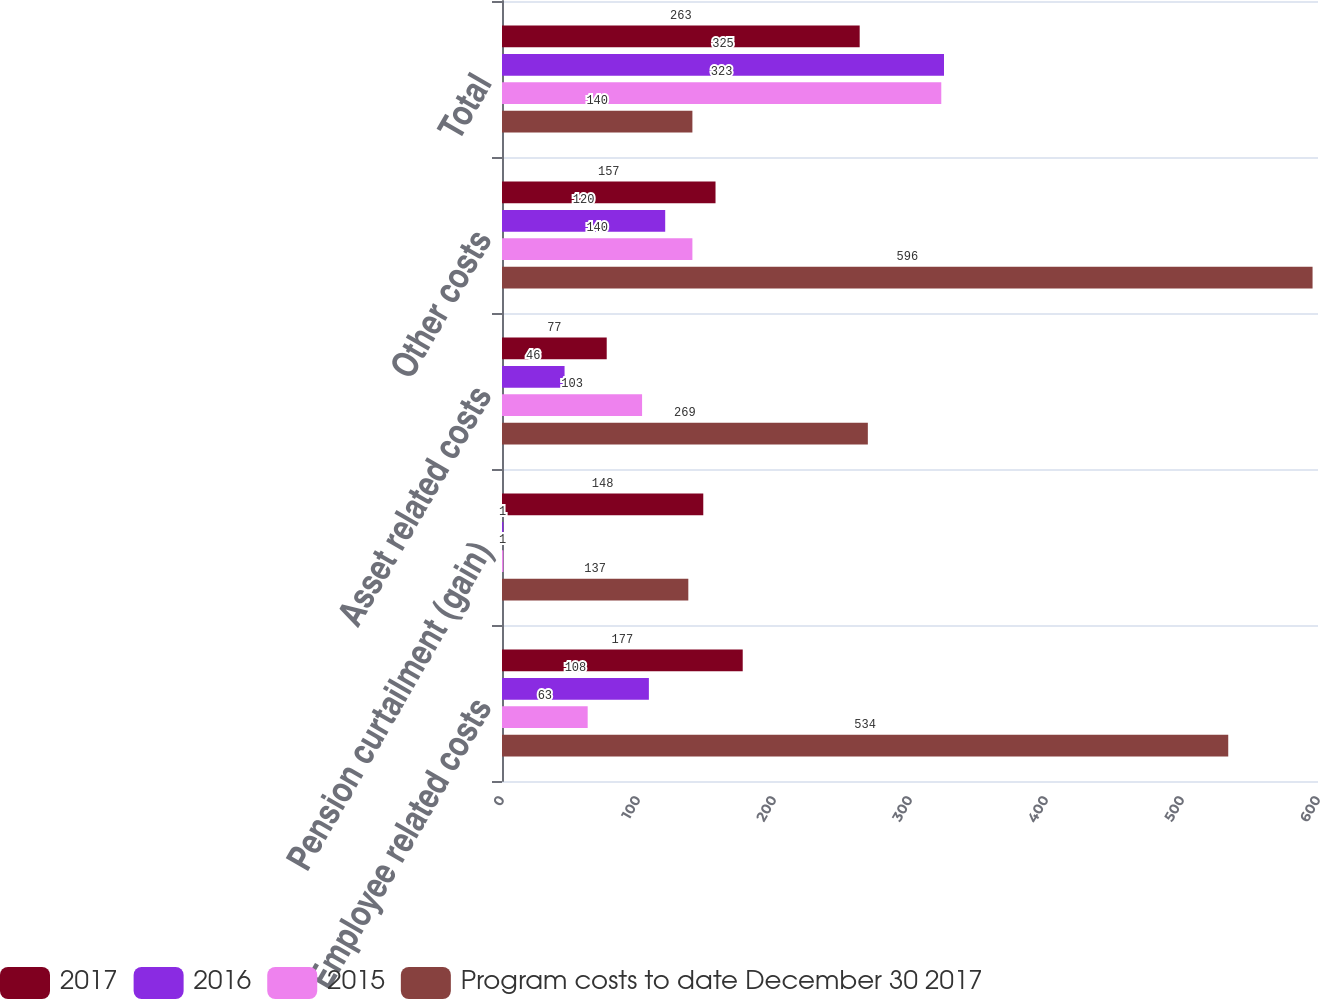<chart> <loc_0><loc_0><loc_500><loc_500><stacked_bar_chart><ecel><fcel>Employee related costs<fcel>Pension curtailment (gain)<fcel>Asset related costs<fcel>Other costs<fcel>Total<nl><fcel>2017<fcel>177<fcel>148<fcel>77<fcel>157<fcel>263<nl><fcel>2016<fcel>108<fcel>1<fcel>46<fcel>120<fcel>325<nl><fcel>2015<fcel>63<fcel>1<fcel>103<fcel>140<fcel>323<nl><fcel>Program costs to date December 30 2017<fcel>534<fcel>137<fcel>269<fcel>596<fcel>140<nl></chart> 